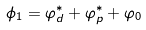<formula> <loc_0><loc_0><loc_500><loc_500>\phi _ { 1 } = \varphi _ { d } ^ { \ast } + \varphi _ { p } ^ { \ast } + \varphi _ { 0 }</formula> 